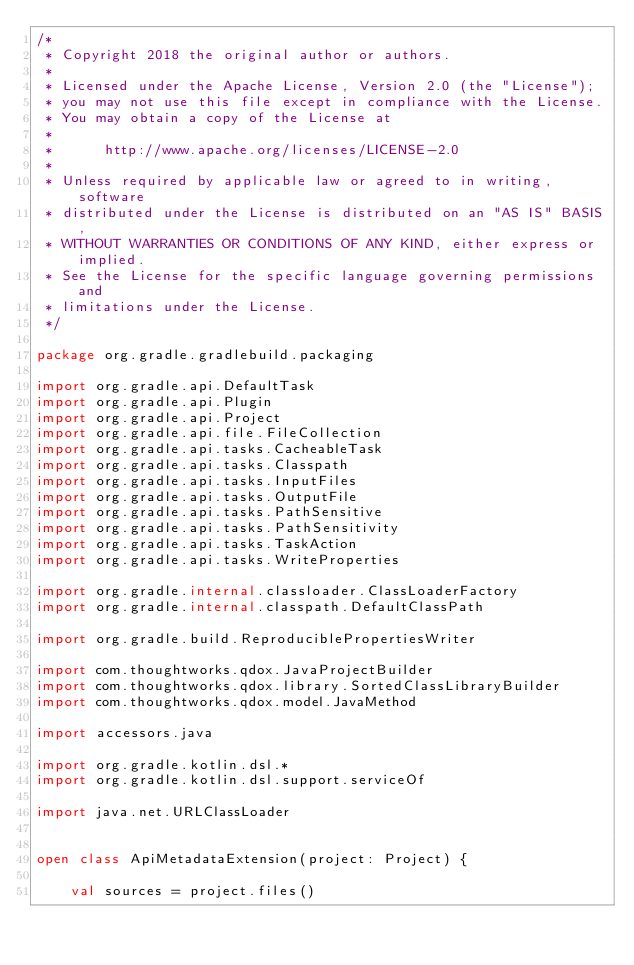Convert code to text. <code><loc_0><loc_0><loc_500><loc_500><_Kotlin_>/*
 * Copyright 2018 the original author or authors.
 *
 * Licensed under the Apache License, Version 2.0 (the "License");
 * you may not use this file except in compliance with the License.
 * You may obtain a copy of the License at
 *
 *      http://www.apache.org/licenses/LICENSE-2.0
 *
 * Unless required by applicable law or agreed to in writing, software
 * distributed under the License is distributed on an "AS IS" BASIS,
 * WITHOUT WARRANTIES OR CONDITIONS OF ANY KIND, either express or implied.
 * See the License for the specific language governing permissions and
 * limitations under the License.
 */

package org.gradle.gradlebuild.packaging

import org.gradle.api.DefaultTask
import org.gradle.api.Plugin
import org.gradle.api.Project
import org.gradle.api.file.FileCollection
import org.gradle.api.tasks.CacheableTask
import org.gradle.api.tasks.Classpath
import org.gradle.api.tasks.InputFiles
import org.gradle.api.tasks.OutputFile
import org.gradle.api.tasks.PathSensitive
import org.gradle.api.tasks.PathSensitivity
import org.gradle.api.tasks.TaskAction
import org.gradle.api.tasks.WriteProperties

import org.gradle.internal.classloader.ClassLoaderFactory
import org.gradle.internal.classpath.DefaultClassPath

import org.gradle.build.ReproduciblePropertiesWriter

import com.thoughtworks.qdox.JavaProjectBuilder
import com.thoughtworks.qdox.library.SortedClassLibraryBuilder
import com.thoughtworks.qdox.model.JavaMethod

import accessors.java

import org.gradle.kotlin.dsl.*
import org.gradle.kotlin.dsl.support.serviceOf

import java.net.URLClassLoader


open class ApiMetadataExtension(project: Project) {

    val sources = project.files()</code> 